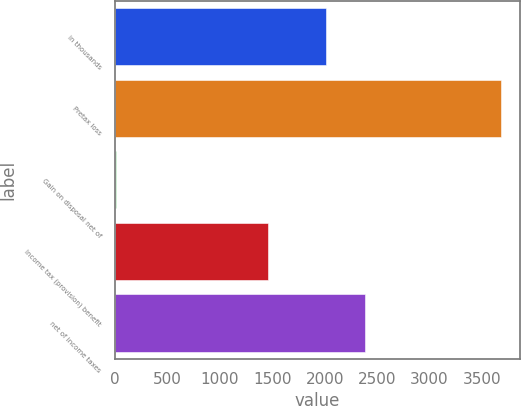<chart> <loc_0><loc_0><loc_500><loc_500><bar_chart><fcel>in thousands<fcel>Pretax loss<fcel>Gain on disposal net of<fcel>Income tax (provision) benefit<fcel>net of income taxes<nl><fcel>2014<fcel>3683<fcel>3.38<fcel>1460<fcel>2381.96<nl></chart> 